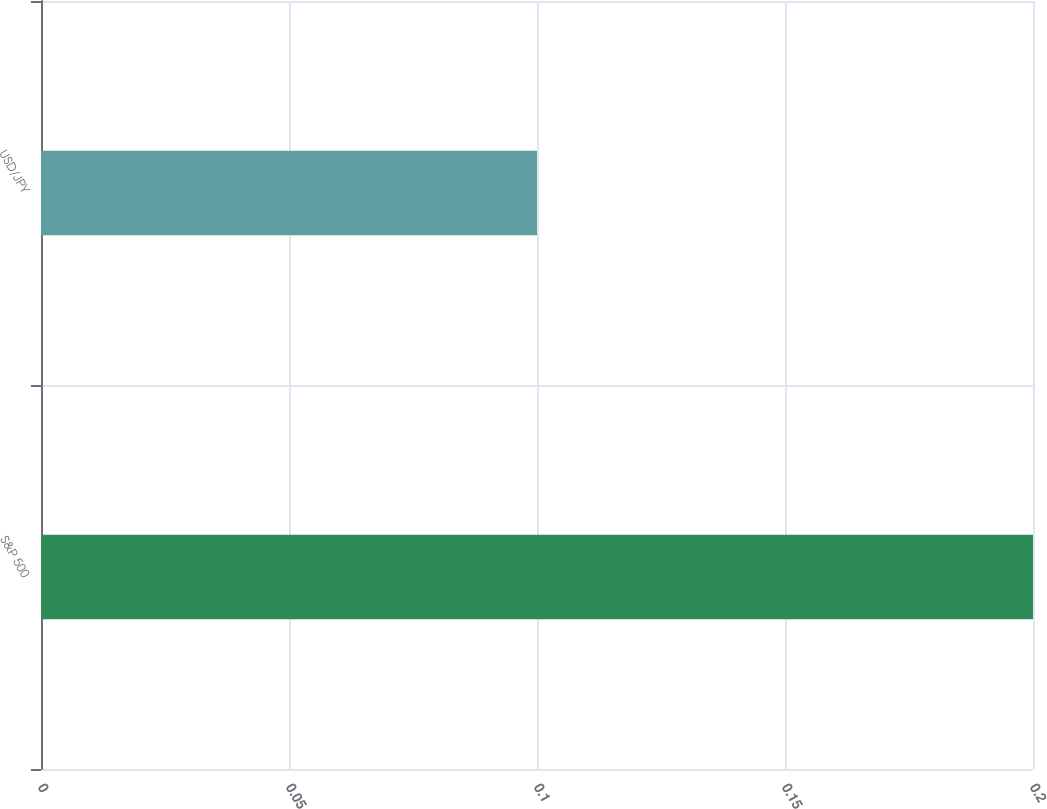Convert chart. <chart><loc_0><loc_0><loc_500><loc_500><bar_chart><fcel>S&P 500<fcel>USD/JPY<nl><fcel>0.2<fcel>0.1<nl></chart> 